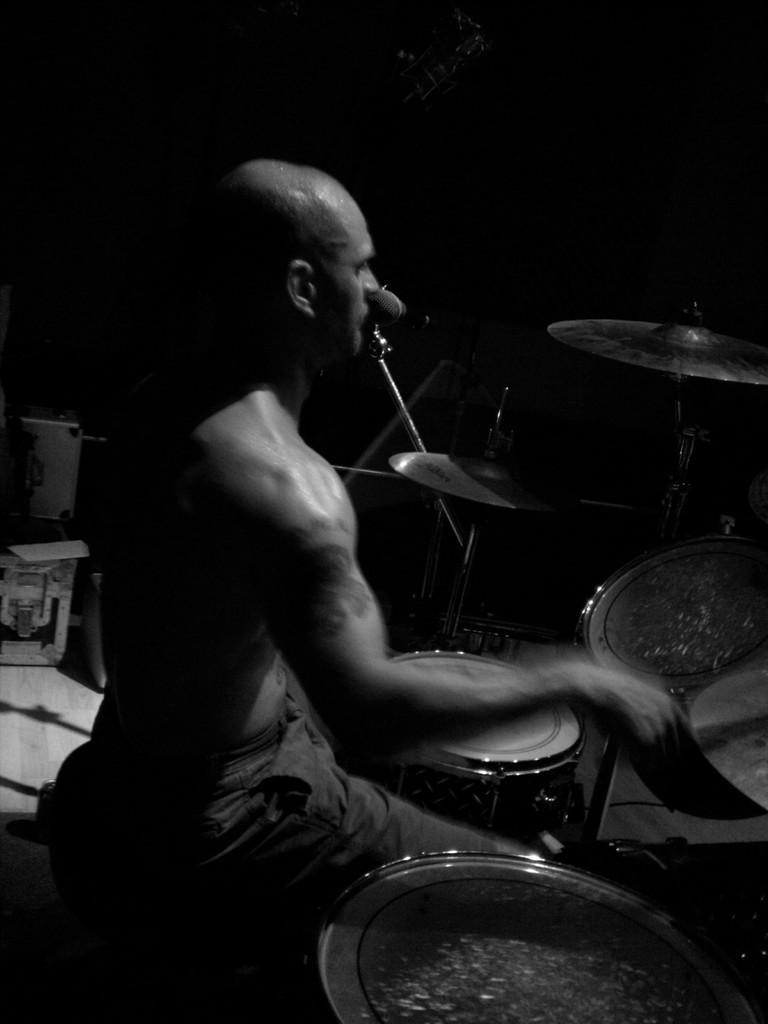Could you give a brief overview of what you see in this image? This is a black and white image where we can see a man is playing drums. We can see some objects on the left side of the image. In the background, we can see a mic and a stand. It seems like a guitar at the top of the image. 